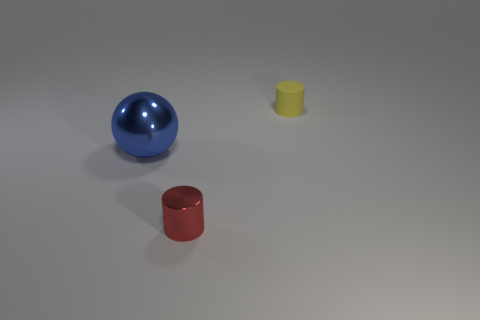Are there any other things that are the same shape as the big blue object?
Give a very brief answer. No. The blue metallic thing is what shape?
Provide a short and direct response. Sphere. There is another red thing that is made of the same material as the big thing; what shape is it?
Give a very brief answer. Cylinder. Do the tiny red object and the tiny object behind the red cylinder have the same shape?
Your answer should be compact. Yes. The tiny thing in front of the metal object behind the red metallic thing is made of what material?
Offer a very short reply. Metal. Is the number of spheres that are to the right of the large blue object the same as the number of green things?
Provide a succinct answer. Yes. Are there any other things that have the same material as the tiny yellow cylinder?
Keep it short and to the point. No. How many things are to the left of the rubber cylinder and behind the red thing?
Make the answer very short. 1. What number of other objects are there of the same shape as the blue object?
Give a very brief answer. 0. Are there more big blue shiny objects behind the red cylinder than red spheres?
Your response must be concise. Yes. 